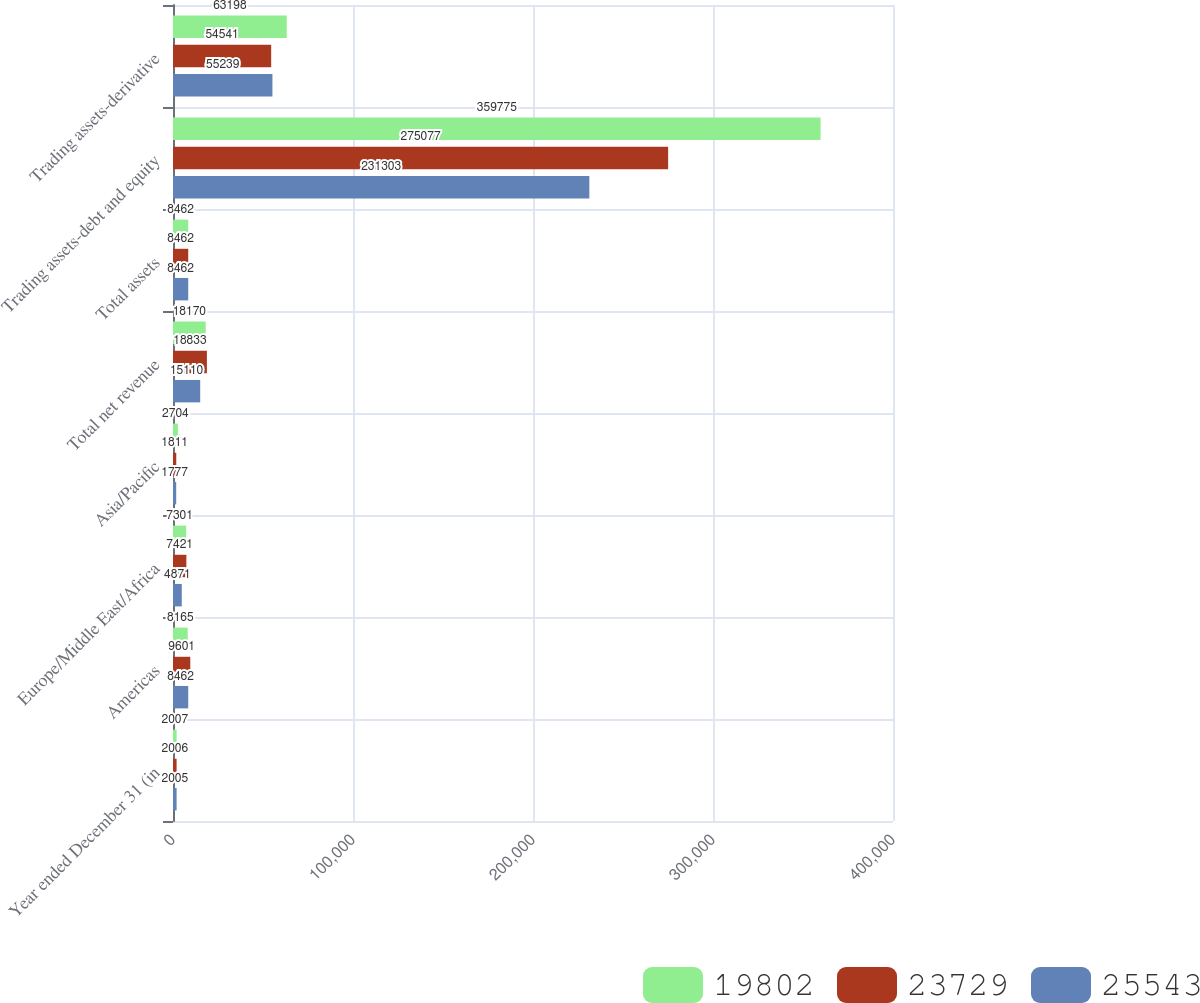<chart> <loc_0><loc_0><loc_500><loc_500><stacked_bar_chart><ecel><fcel>Year ended December 31 (in<fcel>Americas<fcel>Europe/Middle East/Africa<fcel>Asia/Pacific<fcel>Total net revenue<fcel>Total assets<fcel>Trading assets-debt and equity<fcel>Trading assets-derivative<nl><fcel>19802<fcel>2007<fcel>8165<fcel>7301<fcel>2704<fcel>18170<fcel>8462<fcel>359775<fcel>63198<nl><fcel>23729<fcel>2006<fcel>9601<fcel>7421<fcel>1811<fcel>18833<fcel>8462<fcel>275077<fcel>54541<nl><fcel>25543<fcel>2005<fcel>8462<fcel>4871<fcel>1777<fcel>15110<fcel>8462<fcel>231303<fcel>55239<nl></chart> 